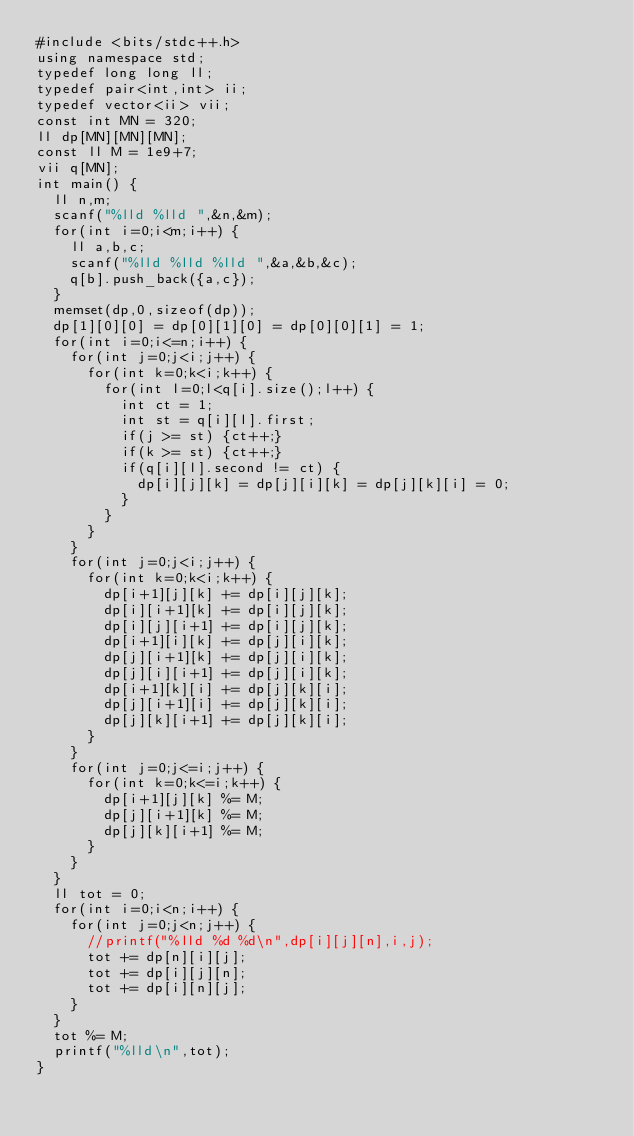<code> <loc_0><loc_0><loc_500><loc_500><_C++_>#include <bits/stdc++.h>
using namespace std;
typedef long long ll;
typedef pair<int,int> ii;
typedef vector<ii> vii;
const int MN = 320;
ll dp[MN][MN][MN];
const ll M = 1e9+7;
vii q[MN];
int main() {
	ll n,m;
	scanf("%lld %lld ",&n,&m);
	for(int i=0;i<m;i++) {
		ll a,b,c;
		scanf("%lld %lld %lld ",&a,&b,&c);
		q[b].push_back({a,c});
	}
	memset(dp,0,sizeof(dp));
	dp[1][0][0] = dp[0][1][0] = dp[0][0][1] = 1;
	for(int i=0;i<=n;i++) {
		for(int j=0;j<i;j++) {
			for(int k=0;k<i;k++) {
				for(int l=0;l<q[i].size();l++) {
					int ct = 1;
					int st = q[i][l].first;
					if(j >= st) {ct++;}
					if(k >= st) {ct++;}
					if(q[i][l].second != ct) {
						dp[i][j][k] = dp[j][i][k] = dp[j][k][i] = 0;
					}
				}
			}
		}
		for(int j=0;j<i;j++) {
			for(int k=0;k<i;k++) {
				dp[i+1][j][k] += dp[i][j][k];
				dp[i][i+1][k] += dp[i][j][k];
				dp[i][j][i+1] += dp[i][j][k];
				dp[i+1][i][k] += dp[j][i][k];
				dp[j][i+1][k] += dp[j][i][k];
				dp[j][i][i+1] += dp[j][i][k];
				dp[i+1][k][i] += dp[j][k][i];
				dp[j][i+1][i] += dp[j][k][i];
				dp[j][k][i+1] += dp[j][k][i];
			}
		}
		for(int j=0;j<=i;j++) {
			for(int k=0;k<=i;k++) {
				dp[i+1][j][k] %= M;
				dp[j][i+1][k] %= M;
				dp[j][k][i+1] %= M;
			}
		}
	}
	ll tot = 0;
	for(int i=0;i<n;i++) {
		for(int j=0;j<n;j++) {
			//printf("%lld %d %d\n",dp[i][j][n],i,j);
			tot += dp[n][i][j];
			tot += dp[i][j][n];
			tot += dp[i][n][j];
		}
	}
	tot %= M;
	printf("%lld\n",tot);
}</code> 